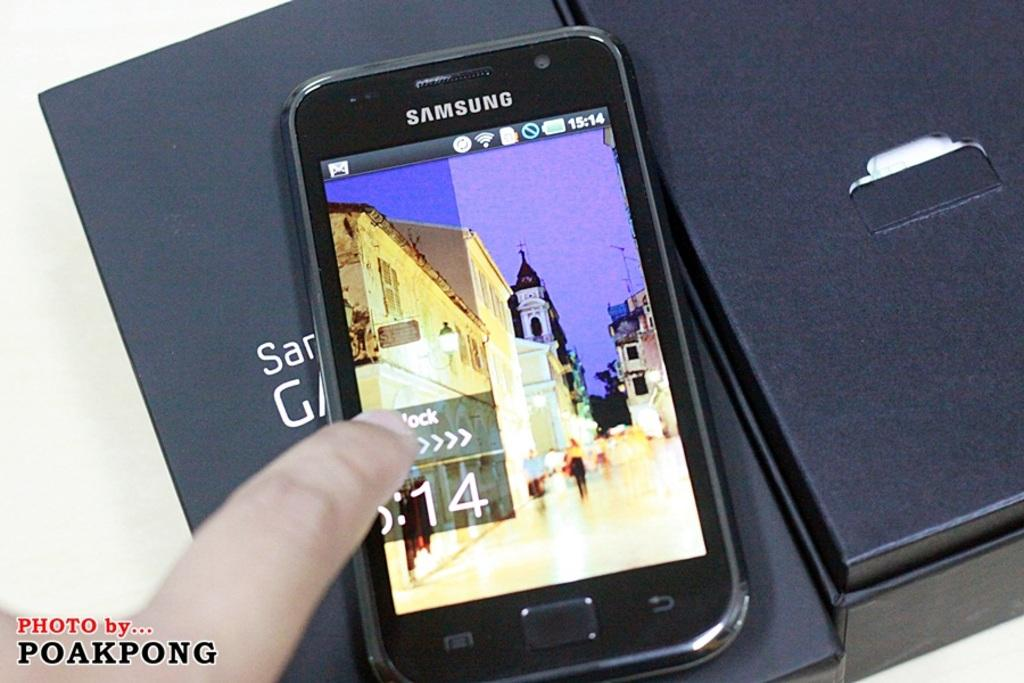<image>
Summarize the visual content of the image. A samsung brand phone rests on its box. 